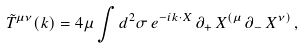Convert formula to latex. <formula><loc_0><loc_0><loc_500><loc_500>\tilde { T } ^ { \mu \nu } ( k ) = 4 \mu \int d ^ { 2 } \sigma \, e ^ { - i k \cdot X } \, \partial _ { + } \, X ^ { ( \mu } \, \partial _ { - } \, X ^ { \nu ) } \, ,</formula> 